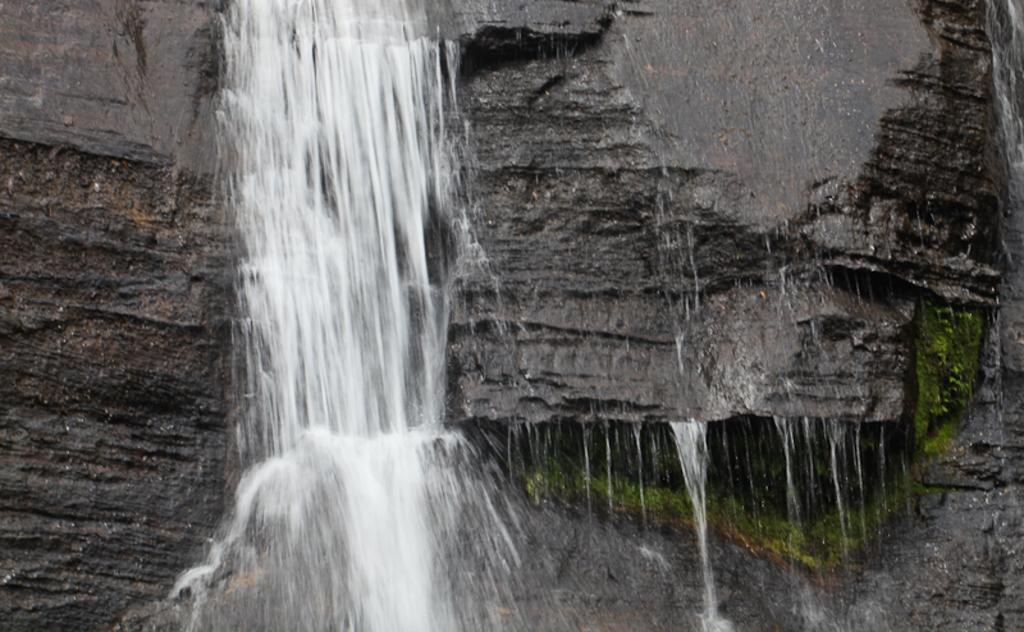What natural feature is present in the image? There are waterfalls in the image. How many visitors can be seen interacting with the waterfalls in the image? There is no reference to any visitors in the image; it only features waterfalls. What type of metal is the waterfall made of in the image? The image does not provide information about the composition of the waterfall, and there is no indication that it is made of any metal, including copper. 